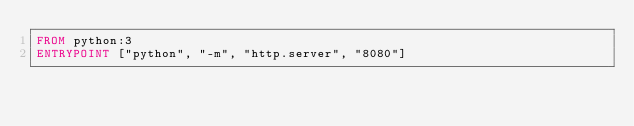Convert code to text. <code><loc_0><loc_0><loc_500><loc_500><_Dockerfile_>FROM python:3
ENTRYPOINT ["python", "-m", "http.server", "8080"]
</code> 